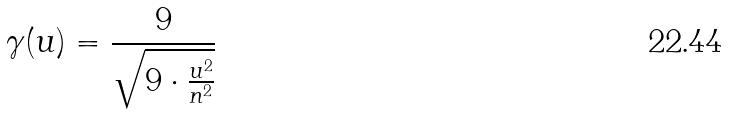<formula> <loc_0><loc_0><loc_500><loc_500>\gamma ( u ) = \frac { 9 } { \sqrt { 9 \cdot \frac { u ^ { 2 } } { n ^ { 2 } } } }</formula> 